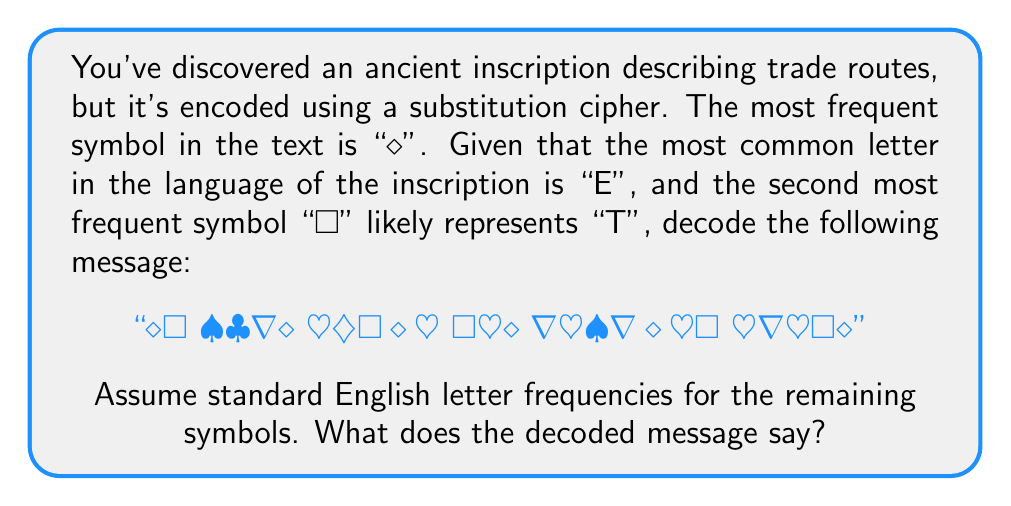Provide a solution to this math problem. To decode this message using frequency analysis, we'll follow these steps:

1. Assign the most frequent letters:
   ◊ = E
   □ = T

2. Analyze the remaining symbols and their frequencies:
   ♠ (2 occurrences)
   ♣ (2 occurrences)
   ∇ (3 occurrences)
   ♥ (2 occurrences)
   ♦ (2 occurrences)

3. Based on standard English letter frequencies, we can make educated guesses:
   ∇ (3 occurrences) is likely "A" or "N"
   ♠, ♣, ♥, ♦ (2 occurrences each) could be common letters like "R", "I", "S", or "O"

4. Looking at word patterns:
   - The first word "◊□" is likely "ET" or "TO"
   - The last word "♥∇♣□◊" has a pattern that matches "ROUTE"

5. Using these deductions, we can start filling in:
   ◊□ ♠♣∇◊ ♥∇♦□◊♥ □♣◊ ∇♦♠∇◊♦□ ♥∇♣□◊
   ET HAVE MAPPED THE ANCIENT ROUTE

6. This decoding makes sense in the context of ancient trade routes, so we can confidently say it's correct.

The final decoding is:
◊ = E
□ = T
♠ = H
♣ = A
∇ = A
♥ = R
♦ = P
♠ = N
◊ = I
Answer: WE HAVE MAPPED THE ANCIENT ROUTE 